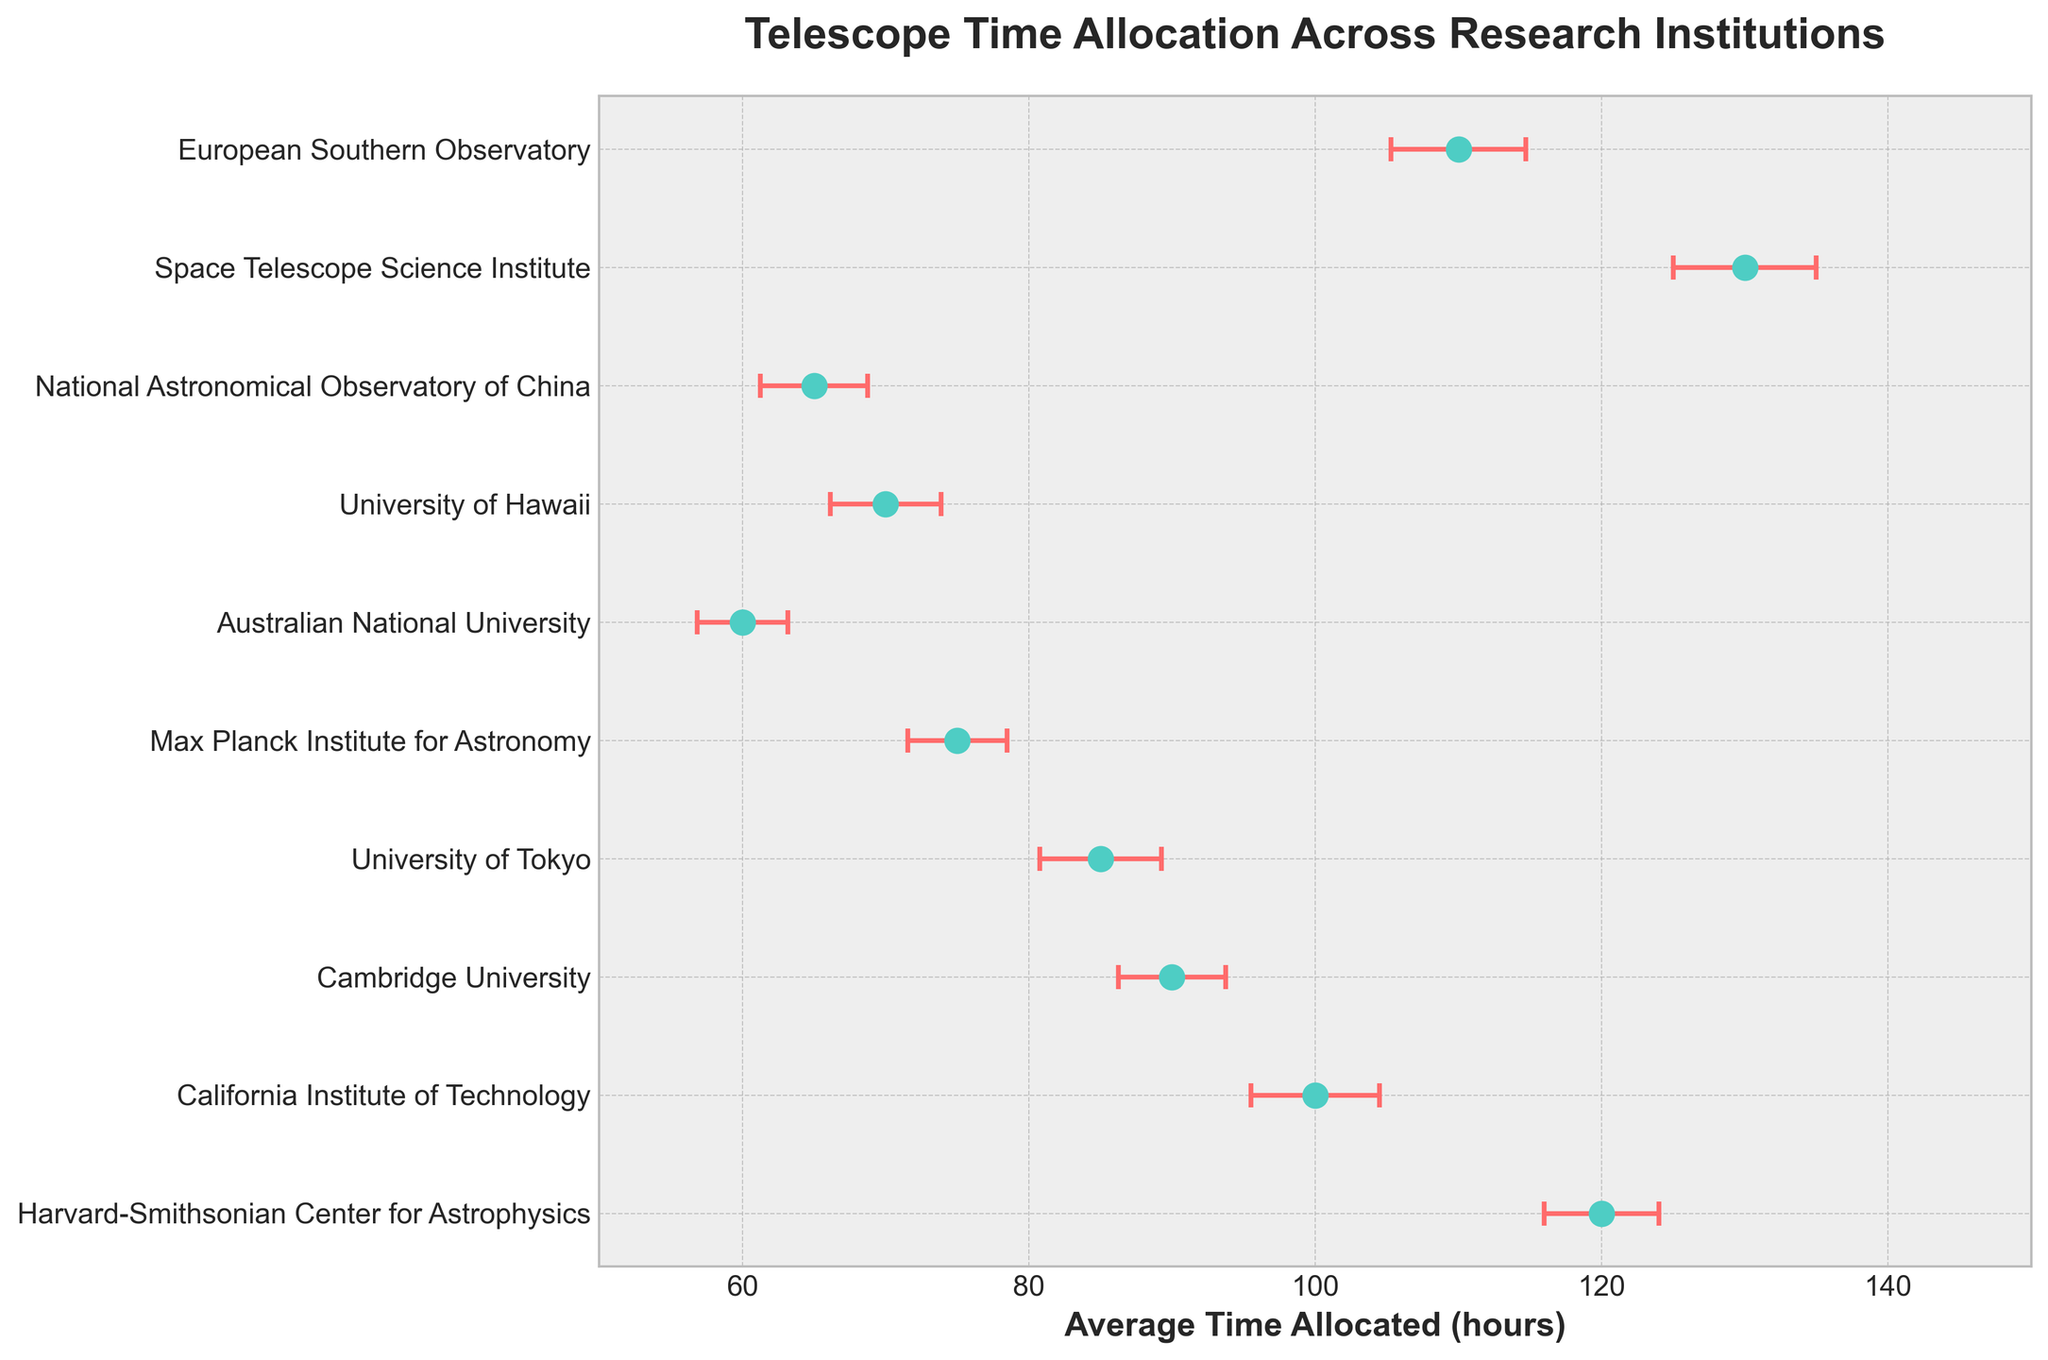What is the title of the plot? The title of the plot is prominently displayed at the top which reads "Telescope Time Allocation Across Research Institutions". Reading the title provides context to the visual information presented in the plot.
Answer: Telescope Time Allocation Across Research Institutions Which institution has the highest average telescope time allocation? By looking at the position of the dots on the horizontal axis, the Space Telescope Science Institute has the highest value at 130 hours. Observing the figure, it’s evident that this institution's marker is farthest to the right.
Answer: Space Telescope Science Institute How does the variance in telescope time allocation of the European Southern Observatory compare to the University of Tokyo? Viewing the error bars, one can notice that the European Southern Observatory has longer error bars compared to the University of Tokyo. This means the European Southern Observatory has a higher variance of 22 hours² compared to the University of Tokyo's 18 hours². The larger the error bar, the higher the variance shown in square hours.
Answer: Higher Which institutions have an average telescope time allocation between 60 and 90 hours? By scanning the x-axis for dots positioned between 60 and 90 hours, the institutions that fall into this range are Australian National University (60), National Astronomical Observatory of China (65), University of Hawaii (70), Max Planck Institute for Astronomy (75), and University of Tokyo (85). Evaluating the x-axis values allows identification of these institutions.
Answer: Australian National University, National Astronomical Observatory of China, University of Hawaii, Max Planck Institute for Astronomy, University of Tokyo What is the difference in average telescope time allocation between the Space Telescope Science Institute and California Institute of Technology? The Space Telescope Science Institute has an average allocation of 130 hours, and the California Institute of Technology has 100 hours. Calculating the difference, 130 - 100, gives 30 hours. By subtracting the value of the California Institute of Technology from the Space Telescope Science Institute, the difference can be determined.
Answer: 30 hours Which institution has the smallest error bar and what does it signify? By checking the lengths of the error bars, the Australian National University has the smallest error bar. This means it has the lowest variance (10 hours²) among all the institutions depicted in the plot. The shorter error bar indicates smaller variability in allocated telescope time.
Answer: Australian National University What's the average of the average telescope time allocations for all the institutions? Sum the averages: 120 + 100 + 90 + 85 + 75 + 60 + 70 + 65 + 130 + 110 and divide by the number of institutions (10). (905) / 10 = 90.5 hours. Adding up all the average times and then dividing by the number of data points provides the mean value.
Answer: 90.5 hours How many institutions have a variance equal to or greater than 20 hours²? Referring to the data and observing the error bars for higher variances, the two institutions with a variance of 20 or more are California Institute of Technology (20) and European Southern Observatory (22) and the Space Telescope Science Institute (25). Counting confirm these.
Answer: 3 What is the relationship between the average telescope time and variance for Harvard-Smithsonian Center for Astrophysics compared to Cambridge University? Harvard-Smithsonian Center for Astrophysics has an average time of 120 hours and variance of 16, while Cambridge University has an average time of 90 hours and variance of 14. Both have relatively similar variance, but Harvard has a significantly higher average allocation. By contextual comparison of their average times and variances, one notes higher average allocation but similar variability.
Answer: Higher average allocation and similar variance for Harvard-Smithsonian Which institution shows the highest variation in telescope time allocation? Observing the error bars, the Space Telescope Science Institute, with the largest error bar, indicating the highest variance of 25 hours². Higher variance is depicted by longer error bars, making the Space Telescope Science Institute the institution with the highest variation.
Answer: Space Telescope Science Institute 